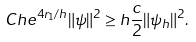<formula> <loc_0><loc_0><loc_500><loc_500>C h e ^ { 4 r _ { 1 } / h } \| \psi \| ^ { 2 } \geq h \frac { c } { 2 } \| \psi _ { h } \| ^ { 2 } .</formula> 